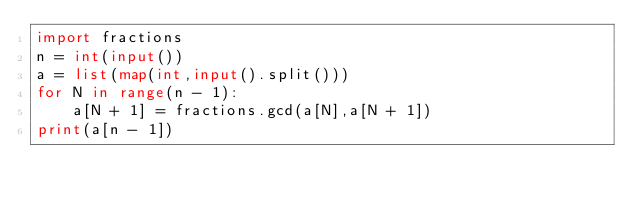Convert code to text. <code><loc_0><loc_0><loc_500><loc_500><_Python_>import fractions
n = int(input())
a = list(map(int,input().split()))
for N in range(n - 1):
    a[N + 1] = fractions.gcd(a[N],a[N + 1])
print(a[n - 1])</code> 